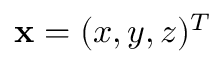<formula> <loc_0><loc_0><loc_500><loc_500>x = ( x , y , z ) ^ { T }</formula> 